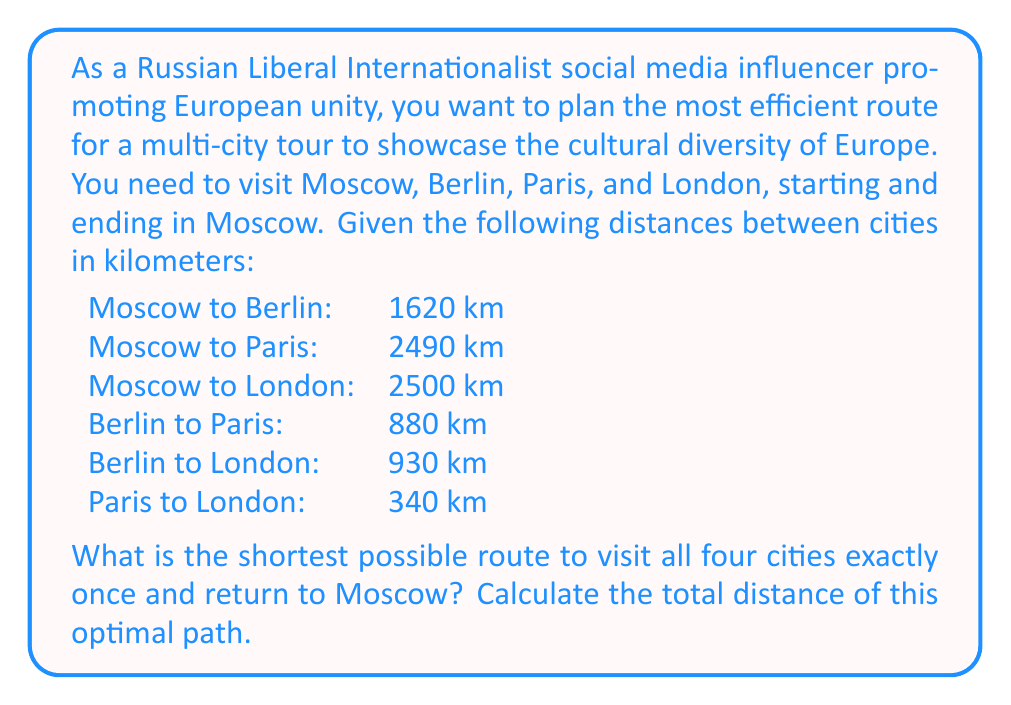Could you help me with this problem? This problem is an application of the Traveling Salesman Problem (TSP) for a small number of cities. With only four cities, we can solve this by considering all possible routes and selecting the shortest one.

Possible routes (starting and ending in Moscow):
1. Moscow - Berlin - Paris - London - Moscow
2. Moscow - Berlin - London - Paris - Moscow
3. Moscow - Paris - Berlin - London - Moscow
4. Moscow - Paris - London - Berlin - Moscow
5. Moscow - London - Berlin - Paris - Moscow
6. Moscow - London - Paris - Berlin - Moscow

Let's calculate the distance for each route:

1. $1620 + 880 + 340 + 2500 = 5340$ km
2. $1620 + 930 + 340 + 2490 = 5380$ km
3. $2490 + 880 + 930 + 1620 = 5920$ km
4. $2490 + 340 + 930 + 1620 = 5380$ km
5. $2500 + 930 + 880 + 2490 = 6800$ km
6. $2500 + 340 + 880 + 1620 = 5340$ km

We can see that routes 1 and 6 tie for the shortest distance at 5340 km.

The optimal path is either:
Moscow - Berlin - Paris - London - Moscow
or
Moscow - London - Paris - Berlin - Moscow
Answer: The shortest possible route is 5340 km, following either the path Moscow - Berlin - Paris - London - Moscow or Moscow - London - Paris - Berlin - Moscow. 